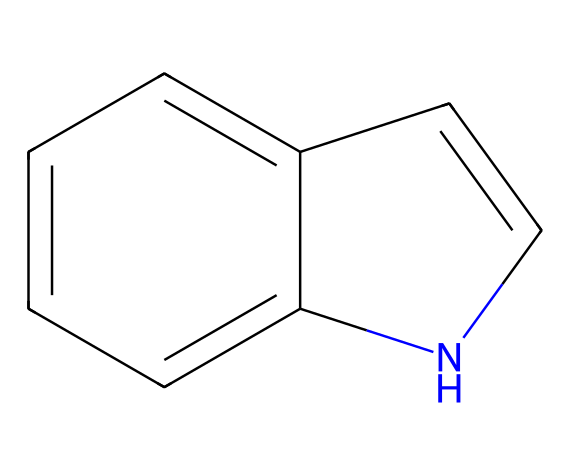What is the total number of carbon atoms in the indole structure? The given SMILES representation indicates the presence of a fused ring system, where the basic structure reveals that there are 8 carbon atoms in total when counting the aromatic and the nitrogen-influenced carbon in the rings.
Answer: eight How many nitrogen atoms are present in indole? In the structure represented by the SMILES, there is one nitrogen atom that participates in the aromatic ring, which can be identified from the 'n' in the SMILES string.
Answer: one How many rings are present in the indole compound? The visual representation shows a two-ring system that forms a fused aromatic structure,明确ly indicating that there are two interconnected rings in the molecular arrangement.
Answer: two What is the type of hybridization of the carbon atoms in indole? The carbon atoms in indole are typically sp2 hybridized, which is characteristic of aromatic compounds, allowing for a planar structure with delocalized π electrons across the ring.
Answer: sp2 What is the characteristic functional group associated with indole? Indole is recognized for its aromatic structure, which primarily consists of a benzene ring fused to a pyrrole ring, defining its classification as an aromatic heterocycle.
Answer: aromatic heterocycle What type of compound is indole categorized as? Indole, due to its nitrogen-containing structure and aromatic properties, is categorized as an aromatic amine, which is specifically characterized by the presence of the nitrogen atom within the aromatic ring system.
Answer: aromatic amine What is a common use of indole in tribal rituals? Indole is often utilized in rituals for its fragrant properties that evoke spiritual or meditative states, commonly used in incense or ceremonial perfumes.
Answer: incense 